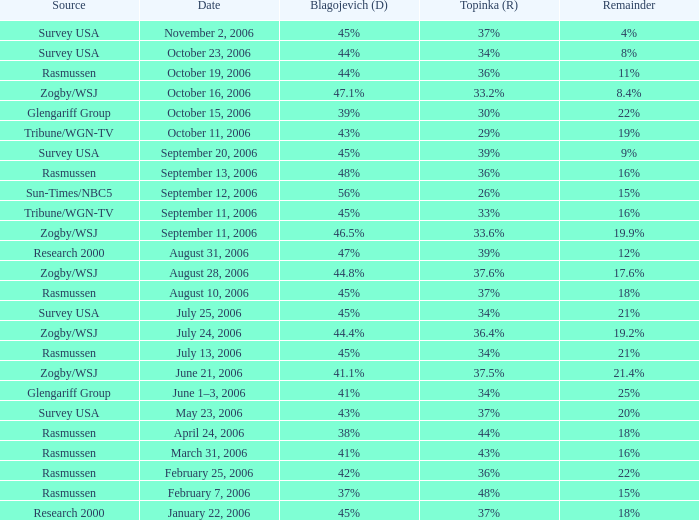Which Topinka happened on january 22, 2006? 37%. 